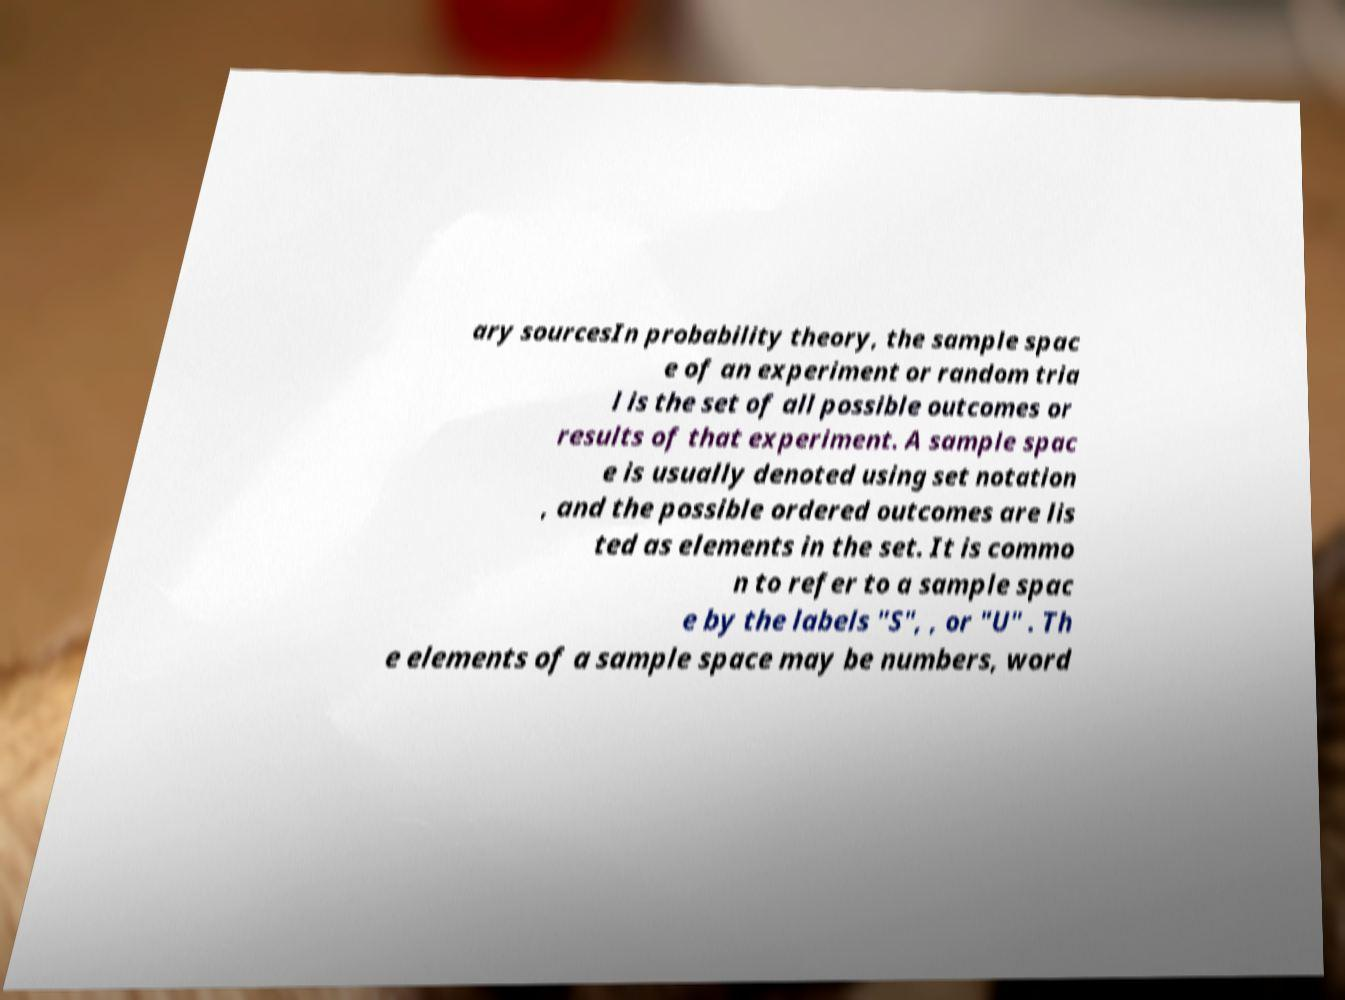What messages or text are displayed in this image? I need them in a readable, typed format. ary sourcesIn probability theory, the sample spac e of an experiment or random tria l is the set of all possible outcomes or results of that experiment. A sample spac e is usually denoted using set notation , and the possible ordered outcomes are lis ted as elements in the set. It is commo n to refer to a sample spac e by the labels "S", , or "U" . Th e elements of a sample space may be numbers, word 